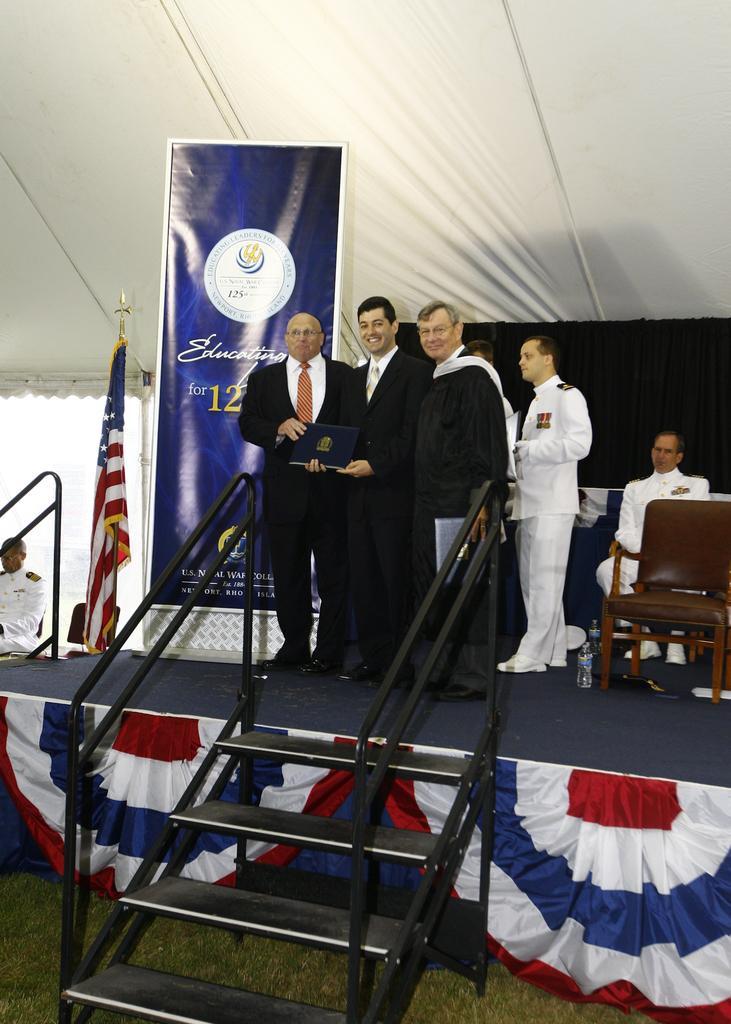Could you give a brief overview of what you see in this image? In this image we can see few people are standing on the stage. This is the banner, chair and flag. This is the staircase. 